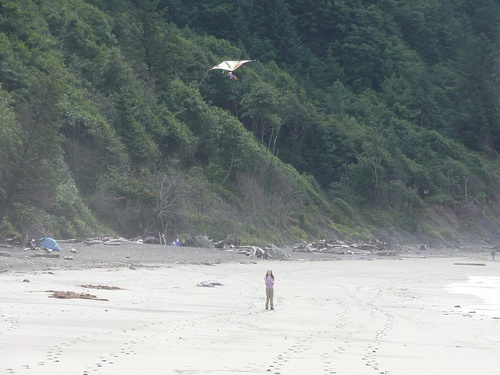Describe the objects in this image and their specific colors. I can see kite in gray, white, darkgray, and purple tones, people in gray, darkgray, lightgray, and violet tones, people in gray, lightgray, and darkgray tones, people in darkgray, lightgray, and gray tones, and people in gray and tan tones in this image. 